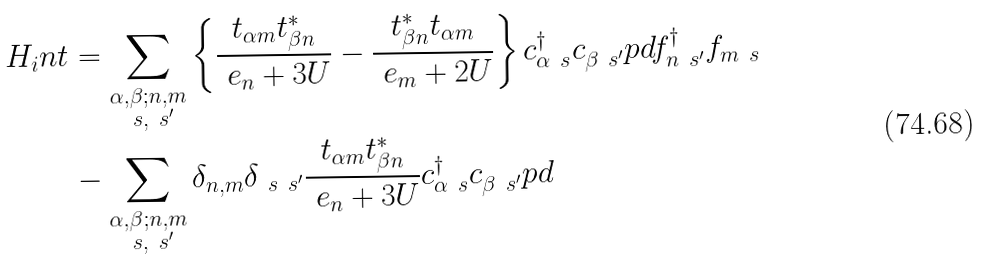Convert formula to latex. <formula><loc_0><loc_0><loc_500><loc_500>H _ { i } n t & = \sum _ { \substack { \alpha , \beta ; n , m \\ \ s , \ s ^ { \prime } } } \left \{ \frac { t _ { \alpha m } t _ { \beta n } ^ { * } } { \ e _ { n } + 3 U } - \frac { t _ { \beta n } ^ { * } t _ { \alpha m } } { \ e _ { m } + 2 U } \right \} c _ { \alpha \ s } ^ { \dag } c _ { \beta \ s ^ { \prime } } ^ { \ } p d f _ { n \ s ^ { \prime } } ^ { \dag } f _ { m \ s } \\ & - \sum _ { \substack { \alpha , \beta ; n , m \\ \ s , \ s ^ { \prime } } } \delta _ { n , m } \delta _ { \ s \ s ^ { \prime } } \frac { t _ { \alpha m } t _ { \beta n } ^ { * } } { \ e _ { n } + 3 U } c _ { \alpha \ s } ^ { \dag } c _ { \beta \ s ^ { \prime } } ^ { \ } p d</formula> 